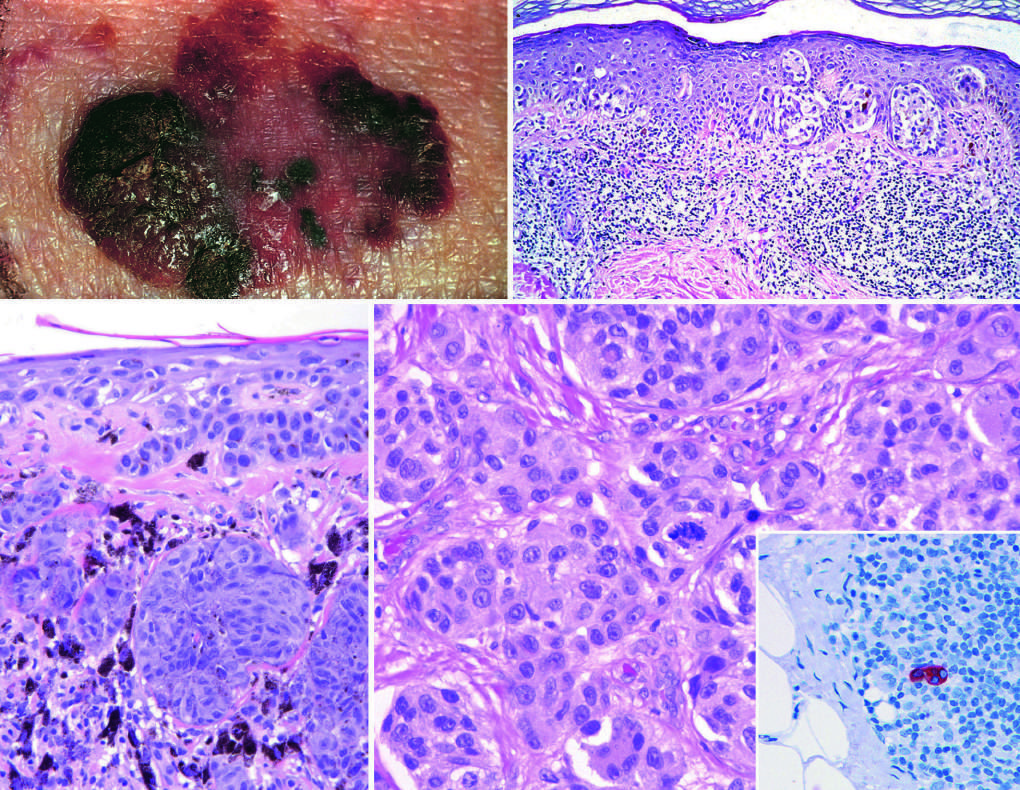does the cyst show a sentinel lymph node containing a tiny cluster of metastatic melanoma, detected by staining for the melanocytic marker hmb-45?
Answer the question using a single word or phrase. No 